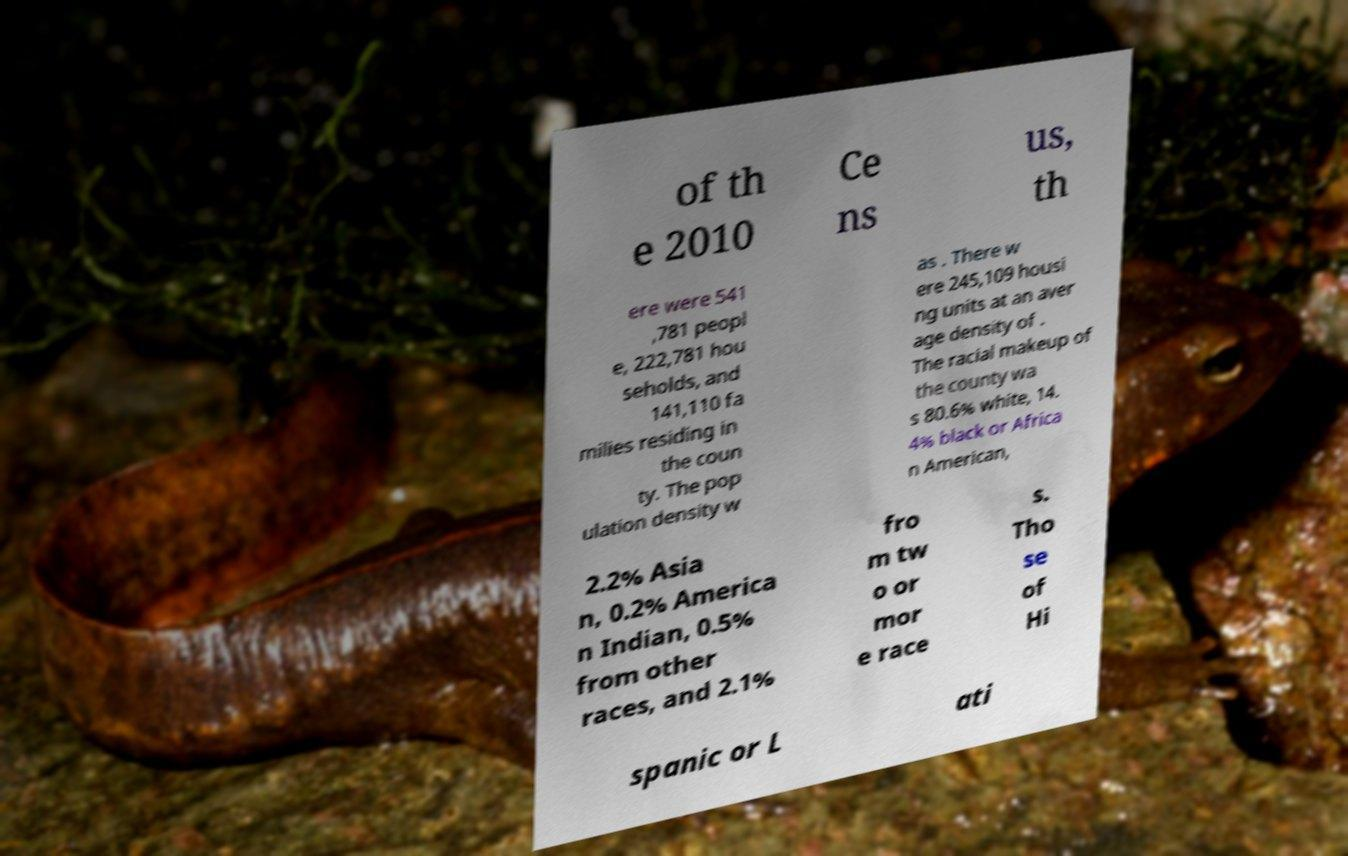What messages or text are displayed in this image? I need them in a readable, typed format. of th e 2010 Ce ns us, th ere were 541 ,781 peopl e, 222,781 hou seholds, and 141,110 fa milies residing in the coun ty. The pop ulation density w as . There w ere 245,109 housi ng units at an aver age density of . The racial makeup of the county wa s 80.6% white, 14. 4% black or Africa n American, 2.2% Asia n, 0.2% America n Indian, 0.5% from other races, and 2.1% fro m tw o or mor e race s. Tho se of Hi spanic or L ati 